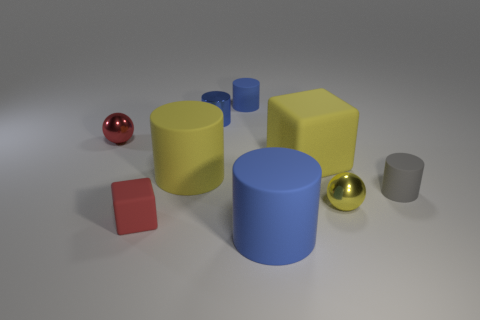Subtract all brown spheres. How many blue cylinders are left? 3 Subtract all purple cylinders. Subtract all yellow spheres. How many cylinders are left? 5 Add 1 shiny spheres. How many objects exist? 10 Subtract all cylinders. How many objects are left? 4 Subtract 0 red cylinders. How many objects are left? 9 Subtract all rubber blocks. Subtract all small yellow rubber balls. How many objects are left? 7 Add 2 yellow objects. How many yellow objects are left? 5 Add 7 big brown metallic objects. How many big brown metallic objects exist? 7 